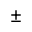<formula> <loc_0><loc_0><loc_500><loc_500>\pm</formula> 